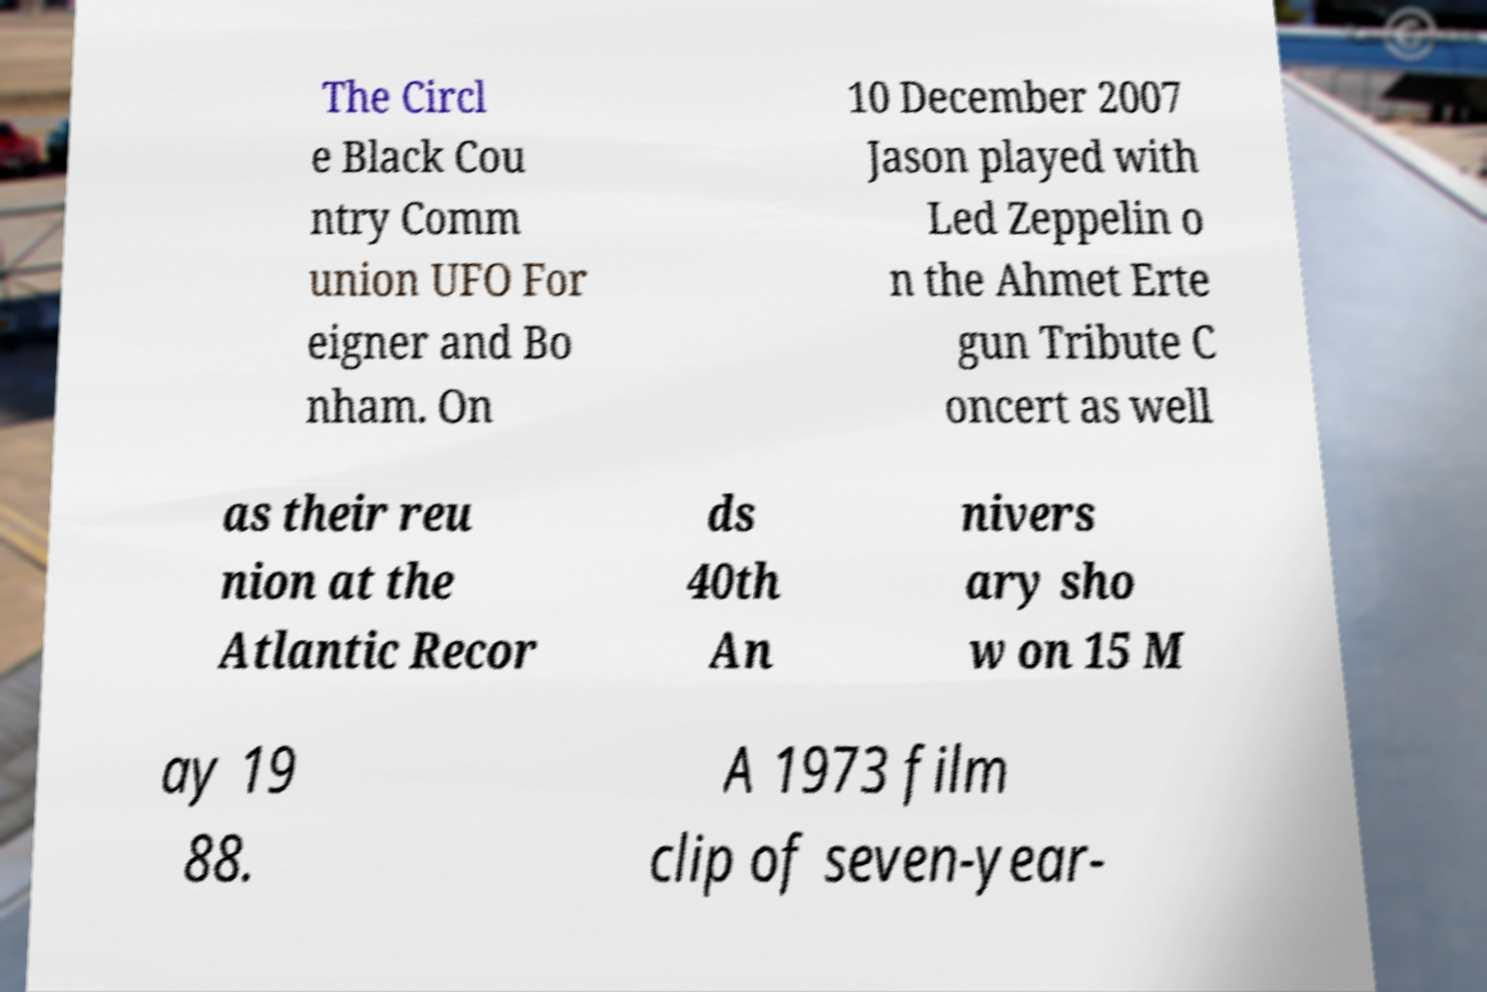I need the written content from this picture converted into text. Can you do that? The Circl e Black Cou ntry Comm union UFO For eigner and Bo nham. On 10 December 2007 Jason played with Led Zeppelin o n the Ahmet Erte gun Tribute C oncert as well as their reu nion at the Atlantic Recor ds 40th An nivers ary sho w on 15 M ay 19 88. A 1973 film clip of seven-year- 